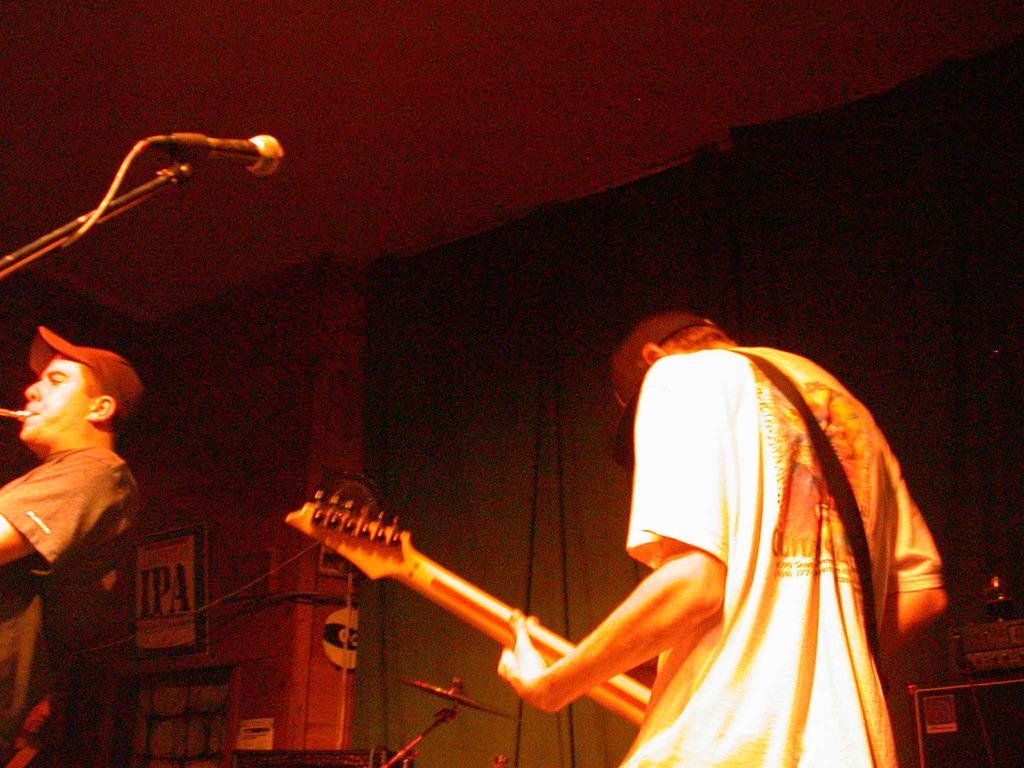How many people are in the image? There are two persons in the image. What is one person doing in the image? One person is playing a guitar. What object is present for amplifying sound in the image? There is a microphone, referred to as "mike," in the image. What can be seen in the background of the image? There is a wall in the background of the image. What type of objects are associated with music in the image? There are musical instruments in the image. What type of glass is being used to play the guitar in the image? There is no glass being used to play the guitar in the image; it is a person playing the guitar with their hands. How many fingers is the person using to play the guitar in the image? It is not possible to determine the exact number of fingers being used to play the guitar in the image, as the person's hands are not fully visible. 